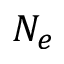Convert formula to latex. <formula><loc_0><loc_0><loc_500><loc_500>N _ { e }</formula> 